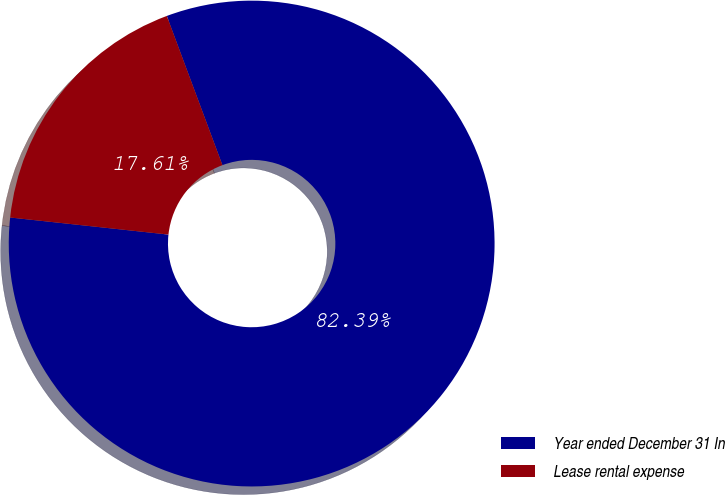Convert chart. <chart><loc_0><loc_0><loc_500><loc_500><pie_chart><fcel>Year ended December 31 In<fcel>Lease rental expense<nl><fcel>82.39%<fcel>17.61%<nl></chart> 